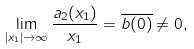Convert formula to latex. <formula><loc_0><loc_0><loc_500><loc_500>\lim _ { | x _ { 1 } | \to \infty } \frac { a _ { 2 } ( x _ { 1 } ) } { x _ { 1 } } = \overline { b ( 0 ) } \neq 0 ,</formula> 